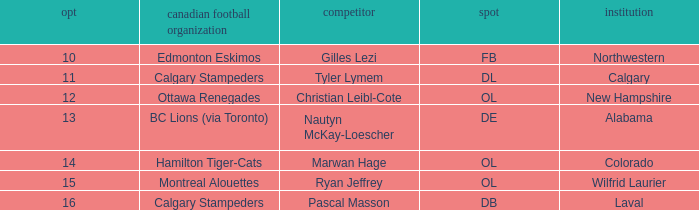What is the pick number for Northwestern college? 10.0. 